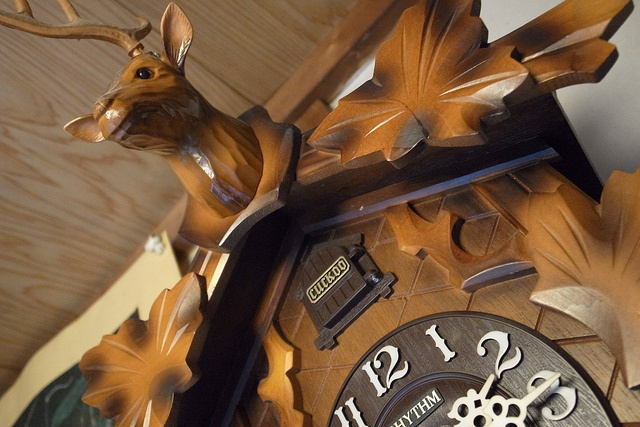Describe the objects in this image and their specific colors. I can see a clock in gray, ivory, black, and maroon tones in this image. 